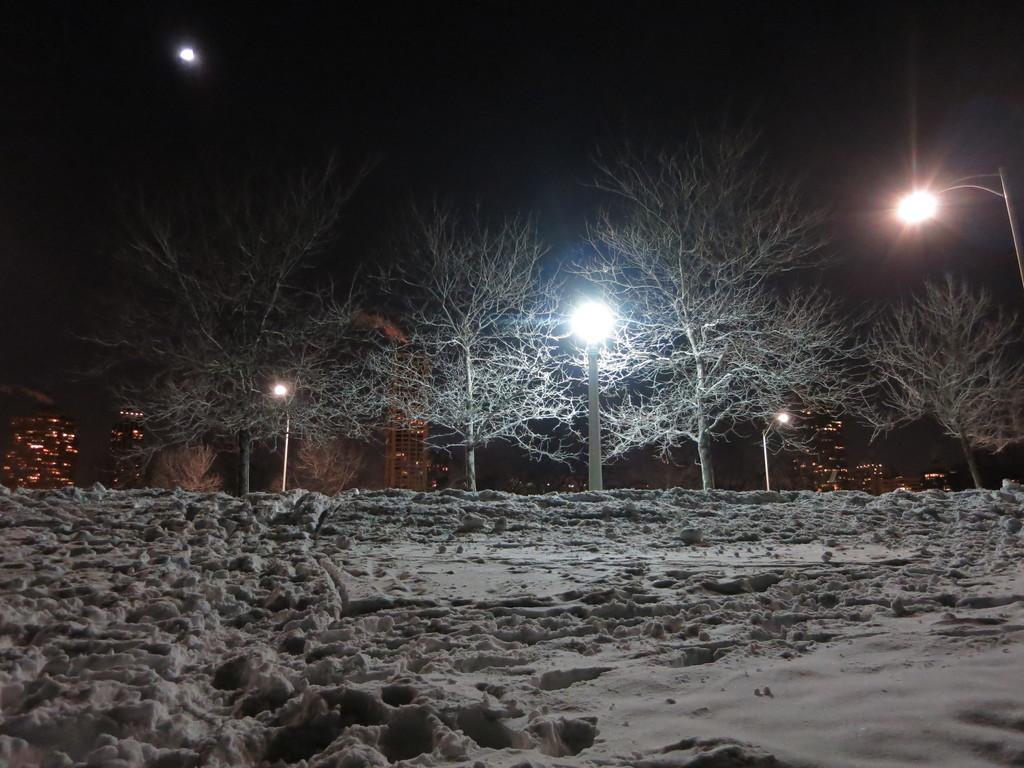Describe this image in one or two sentences. In this image there is sand on the ground. There are trees and street light poles on the ground. In the background there are buildings. At the top it is dark. 